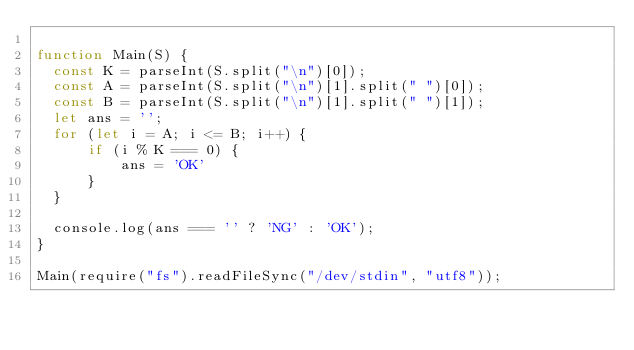<code> <loc_0><loc_0><loc_500><loc_500><_JavaScript_>
function Main(S) {
  const K = parseInt(S.split("\n")[0]);
  const A = parseInt(S.split("\n")[1].split(" ")[0]);
  const B = parseInt(S.split("\n")[1].split(" ")[1]);
  let ans = '';
  for (let i = A; i <= B; i++) {
      if (i % K === 0) {
          ans = 'OK'
      }
  }

  console.log(ans === '' ? 'NG' : 'OK');
}

Main(require("fs").readFileSync("/dev/stdin", "utf8"));</code> 